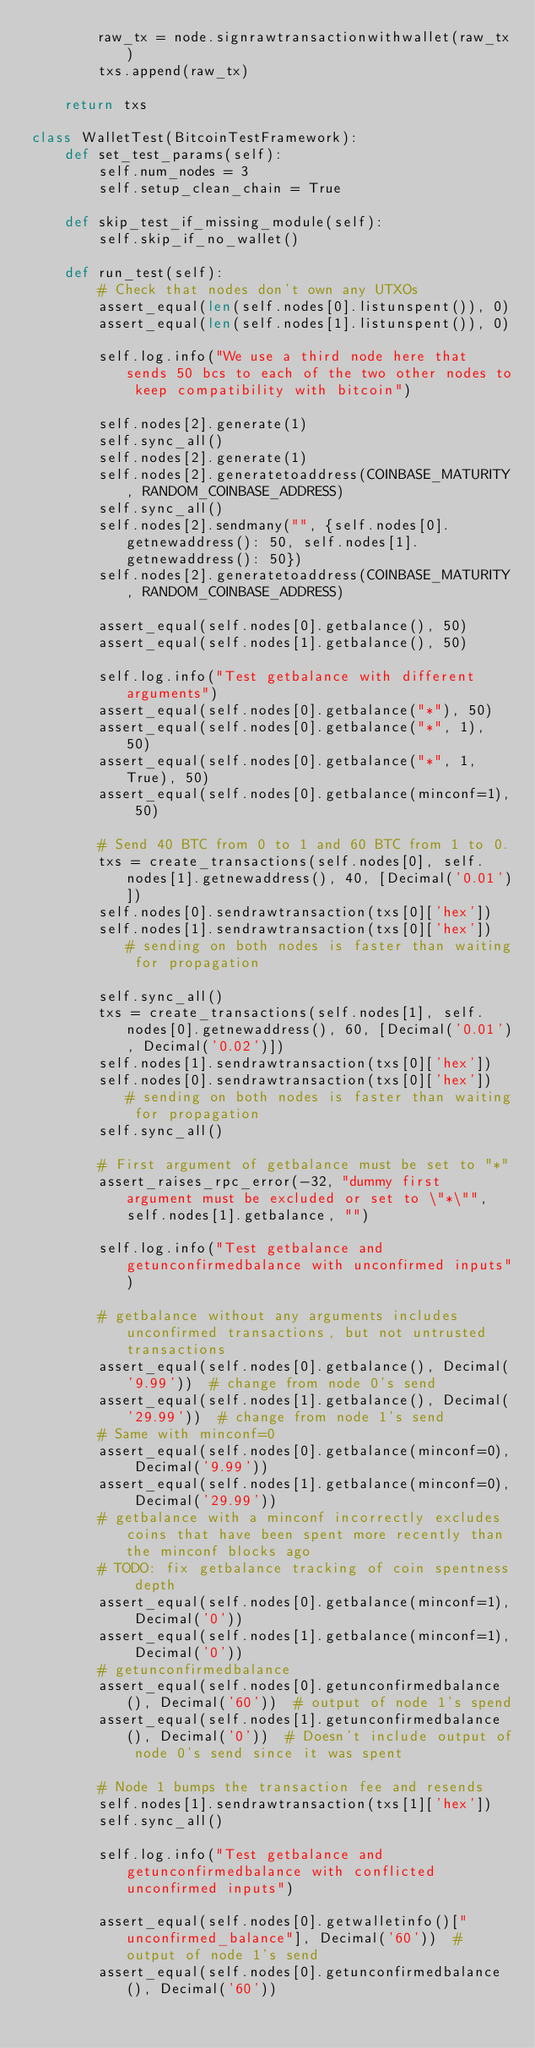Convert code to text. <code><loc_0><loc_0><loc_500><loc_500><_Python_>        raw_tx = node.signrawtransactionwithwallet(raw_tx)
        txs.append(raw_tx)

    return txs

class WalletTest(BitcoinTestFramework):
    def set_test_params(self):
        self.num_nodes = 3
        self.setup_clean_chain = True

    def skip_test_if_missing_module(self):
        self.skip_if_no_wallet()

    def run_test(self):
        # Check that nodes don't own any UTXOs
        assert_equal(len(self.nodes[0].listunspent()), 0)
        assert_equal(len(self.nodes[1].listunspent()), 0)

        self.log.info("We use a third node here that sends 50 bcs to each of the two other nodes to keep compatibility with bitcoin")

        self.nodes[2].generate(1)
        self.sync_all()
        self.nodes[2].generate(1)
        self.nodes[2].generatetoaddress(COINBASE_MATURITY, RANDOM_COINBASE_ADDRESS)
        self.sync_all()
        self.nodes[2].sendmany("", {self.nodes[0].getnewaddress(): 50, self.nodes[1].getnewaddress(): 50})
        self.nodes[2].generatetoaddress(COINBASE_MATURITY, RANDOM_COINBASE_ADDRESS)

        assert_equal(self.nodes[0].getbalance(), 50)
        assert_equal(self.nodes[1].getbalance(), 50)

        self.log.info("Test getbalance with different arguments")
        assert_equal(self.nodes[0].getbalance("*"), 50)
        assert_equal(self.nodes[0].getbalance("*", 1), 50)
        assert_equal(self.nodes[0].getbalance("*", 1, True), 50)
        assert_equal(self.nodes[0].getbalance(minconf=1), 50)

        # Send 40 BTC from 0 to 1 and 60 BTC from 1 to 0.
        txs = create_transactions(self.nodes[0], self.nodes[1].getnewaddress(), 40, [Decimal('0.01')])
        self.nodes[0].sendrawtransaction(txs[0]['hex'])
        self.nodes[1].sendrawtransaction(txs[0]['hex'])  # sending on both nodes is faster than waiting for propagation

        self.sync_all()
        txs = create_transactions(self.nodes[1], self.nodes[0].getnewaddress(), 60, [Decimal('0.01'), Decimal('0.02')])
        self.nodes[1].sendrawtransaction(txs[0]['hex'])
        self.nodes[0].sendrawtransaction(txs[0]['hex'])  # sending on both nodes is faster than waiting for propagation
        self.sync_all()

        # First argument of getbalance must be set to "*"
        assert_raises_rpc_error(-32, "dummy first argument must be excluded or set to \"*\"", self.nodes[1].getbalance, "")

        self.log.info("Test getbalance and getunconfirmedbalance with unconfirmed inputs")

        # getbalance without any arguments includes unconfirmed transactions, but not untrusted transactions
        assert_equal(self.nodes[0].getbalance(), Decimal('9.99'))  # change from node 0's send
        assert_equal(self.nodes[1].getbalance(), Decimal('29.99'))  # change from node 1's send
        # Same with minconf=0
        assert_equal(self.nodes[0].getbalance(minconf=0), Decimal('9.99'))
        assert_equal(self.nodes[1].getbalance(minconf=0), Decimal('29.99'))
        # getbalance with a minconf incorrectly excludes coins that have been spent more recently than the minconf blocks ago
        # TODO: fix getbalance tracking of coin spentness depth
        assert_equal(self.nodes[0].getbalance(minconf=1), Decimal('0'))
        assert_equal(self.nodes[1].getbalance(minconf=1), Decimal('0'))
        # getunconfirmedbalance
        assert_equal(self.nodes[0].getunconfirmedbalance(), Decimal('60'))  # output of node 1's spend
        assert_equal(self.nodes[1].getunconfirmedbalance(), Decimal('0'))  # Doesn't include output of node 0's send since it was spent

        # Node 1 bumps the transaction fee and resends
        self.nodes[1].sendrawtransaction(txs[1]['hex'])
        self.sync_all()

        self.log.info("Test getbalance and getunconfirmedbalance with conflicted unconfirmed inputs")

        assert_equal(self.nodes[0].getwalletinfo()["unconfirmed_balance"], Decimal('60'))  # output of node 1's send
        assert_equal(self.nodes[0].getunconfirmedbalance(), Decimal('60'))</code> 